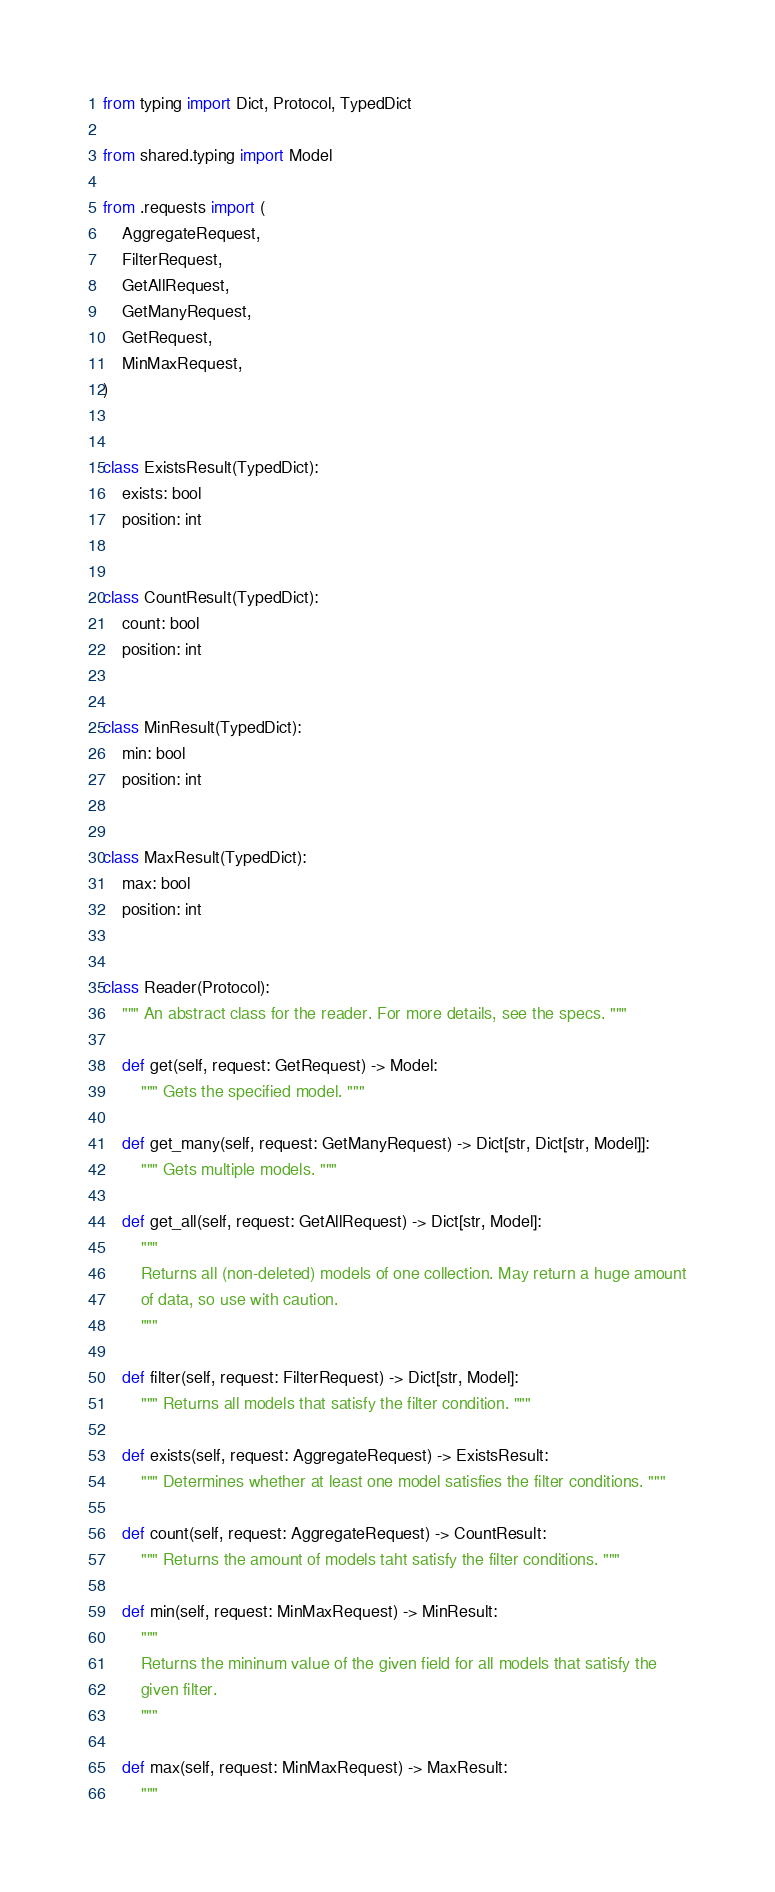Convert code to text. <code><loc_0><loc_0><loc_500><loc_500><_Python_>from typing import Dict, Protocol, TypedDict

from shared.typing import Model

from .requests import (
    AggregateRequest,
    FilterRequest,
    GetAllRequest,
    GetManyRequest,
    GetRequest,
    MinMaxRequest,
)


class ExistsResult(TypedDict):
    exists: bool
    position: int


class CountResult(TypedDict):
    count: bool
    position: int


class MinResult(TypedDict):
    min: bool
    position: int


class MaxResult(TypedDict):
    max: bool
    position: int


class Reader(Protocol):
    """ An abstract class for the reader. For more details, see the specs. """

    def get(self, request: GetRequest) -> Model:
        """ Gets the specified model. """

    def get_many(self, request: GetManyRequest) -> Dict[str, Dict[str, Model]]:
        """ Gets multiple models. """

    def get_all(self, request: GetAllRequest) -> Dict[str, Model]:
        """
        Returns all (non-deleted) models of one collection. May return a huge amount
        of data, so use with caution.
        """

    def filter(self, request: FilterRequest) -> Dict[str, Model]:
        """ Returns all models that satisfy the filter condition. """

    def exists(self, request: AggregateRequest) -> ExistsResult:
        """ Determines whether at least one model satisfies the filter conditions. """

    def count(self, request: AggregateRequest) -> CountResult:
        """ Returns the amount of models taht satisfy the filter conditions. """

    def min(self, request: MinMaxRequest) -> MinResult:
        """
        Returns the mininum value of the given field for all models that satisfy the
        given filter.
        """

    def max(self, request: MinMaxRequest) -> MaxResult:
        """</code> 